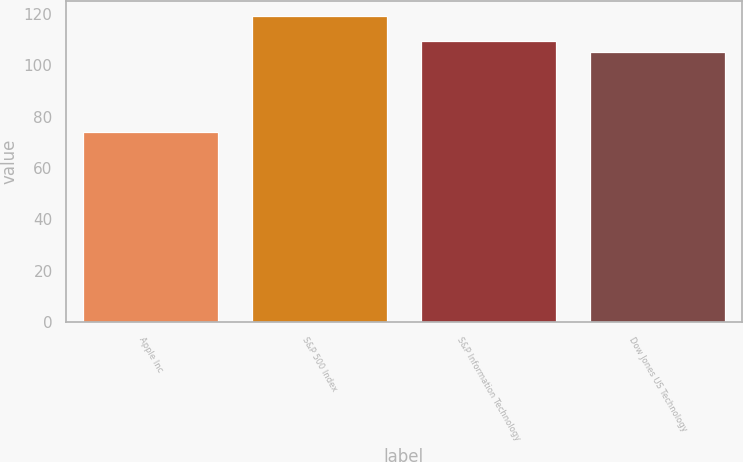Convert chart to OTSL. <chart><loc_0><loc_0><loc_500><loc_500><bar_chart><fcel>Apple Inc<fcel>S&P 500 Index<fcel>S&P Information Technology<fcel>Dow Jones US Technology<nl><fcel>74<fcel>119<fcel>109.5<fcel>105<nl></chart> 